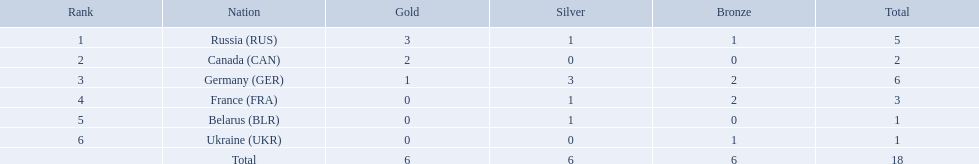What are all the countries in the 1994 winter olympics biathlon? Russia (RUS), Canada (CAN), Germany (GER), France (FRA), Belarus (BLR), Ukraine (UKR). Which of these received at least one gold medal? Russia (RUS), Canada (CAN), Germany (GER). Which of these received no silver or bronze medals? Canada (CAN). Which countries received gold medals? Russia (RUS), Canada (CAN), Germany (GER). Of these countries, which did not receive a silver medal? Canada (CAN). Which nations participated? Russia (RUS), Canada (CAN), Germany (GER), France (FRA), Belarus (BLR), Ukraine (UKR). And how many gold medals did they win? 3, 2, 1, 0, 0, 0. What about silver medals? 1, 0, 3, 1, 1, 0. And bronze? 1, 0, 2, 2, 0, 1. Which nation only won gold medals? Canada (CAN). In which countries were gold medals awarded? Russia (RUS), Canada (CAN), Germany (GER). From these countries, which did not receive a silver medal? Canada (CAN). Which countries were involved in the 1995 biathlon competition? Russia (RUS), Canada (CAN), Germany (GER), France (FRA), Belarus (BLR), Ukraine (UKR). How many medals were won altogether? 5, 2, 6, 3, 1, 1. And which country claimed the most? Germany (GER). What are all the nations in the 1994 winter olympics biathlon? Russia (RUS), Canada (CAN), Germany (GER), France (FRA), Belarus (BLR), Ukraine (UKR). Which of these obtained a minimum of one gold medal? Russia (RUS), Canada (CAN), Germany (GER). Which of these acquired no silver or bronze medals? Canada (CAN). What are all the countries participating in the 1994 winter olympics biathlon? Russia (RUS), Canada (CAN), Germany (GER), France (FRA), Belarus (BLR), Ukraine (UKR). Which of these won at least one gold medal? Russia (RUS), Canada (CAN), Germany (GER). Which of these did not win any silver or bronze medals? Canada (CAN). Which states were involved? Russia (RUS), Canada (CAN), Germany (GER), France (FRA), Belarus (BLR), Ukraine (UKR). And how many gold medals did they achieve? 3, 2, 1, 0, 0, 0. What about silver medals? 1, 0, 3, 1, 1, 0. I'm looking to parse the entire table for insights. Could you assist me with that? {'header': ['Rank', 'Nation', 'Gold', 'Silver', 'Bronze', 'Total'], 'rows': [['1', 'Russia\xa0(RUS)', '3', '1', '1', '5'], ['2', 'Canada\xa0(CAN)', '2', '0', '0', '2'], ['3', 'Germany\xa0(GER)', '1', '3', '2', '6'], ['4', 'France\xa0(FRA)', '0', '1', '2', '3'], ['5', 'Belarus\xa0(BLR)', '0', '1', '0', '1'], ['6', 'Ukraine\xa0(UKR)', '0', '0', '1', '1'], ['', 'Total', '6', '6', '6', '18']]} And bronze? 1, 0, 2, 2, 0, 1. Which state solely won gold medals? Canada (CAN). In which nations did athletes win one or more gold medals? Russia (RUS), Canada (CAN), Germany (GER). Among these nations, which ones also secured a minimum of one silver medal? Russia (RUS), Germany (GER). Out of the remaining nations, which had the highest total medal count? Germany (GER). Which countries managed to win one or more gold medals? Russia (RUS), Canada (CAN), Germany (GER). From these countries, which ones also achieved at least one silver medal? Russia (RUS), Germany (GER). Of the leftover countries, which one had the most overall medals? Germany (GER). 